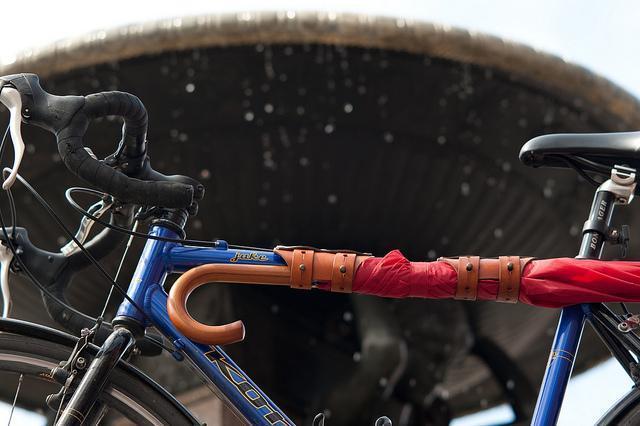The cyclist is most prepared for which weather today?
From the following four choices, select the correct answer to address the question.
Options: Tornado, rain, earthquake, tsunami. Rain. 